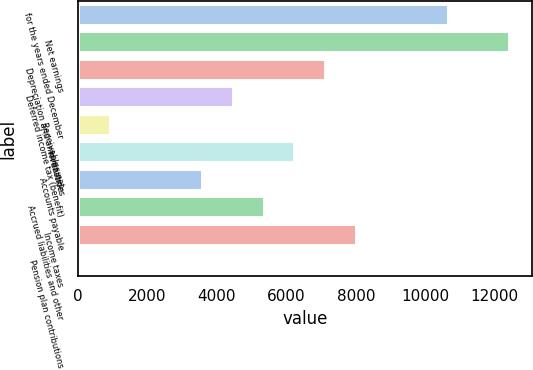Convert chart to OTSL. <chart><loc_0><loc_0><loc_500><loc_500><bar_chart><fcel>for the years ended December<fcel>Net earnings<fcel>Depreciation and amortization<fcel>Deferred income tax (benefit)<fcel>Receivables net<fcel>Inventories<fcel>Accounts payable<fcel>Accrued liabilities and other<fcel>Income taxes<fcel>Pension plan contributions<nl><fcel>10681.2<fcel>12450.4<fcel>7142.8<fcel>4489<fcel>950.6<fcel>6258.2<fcel>3604.4<fcel>5373.6<fcel>8027.4<fcel>66<nl></chart> 